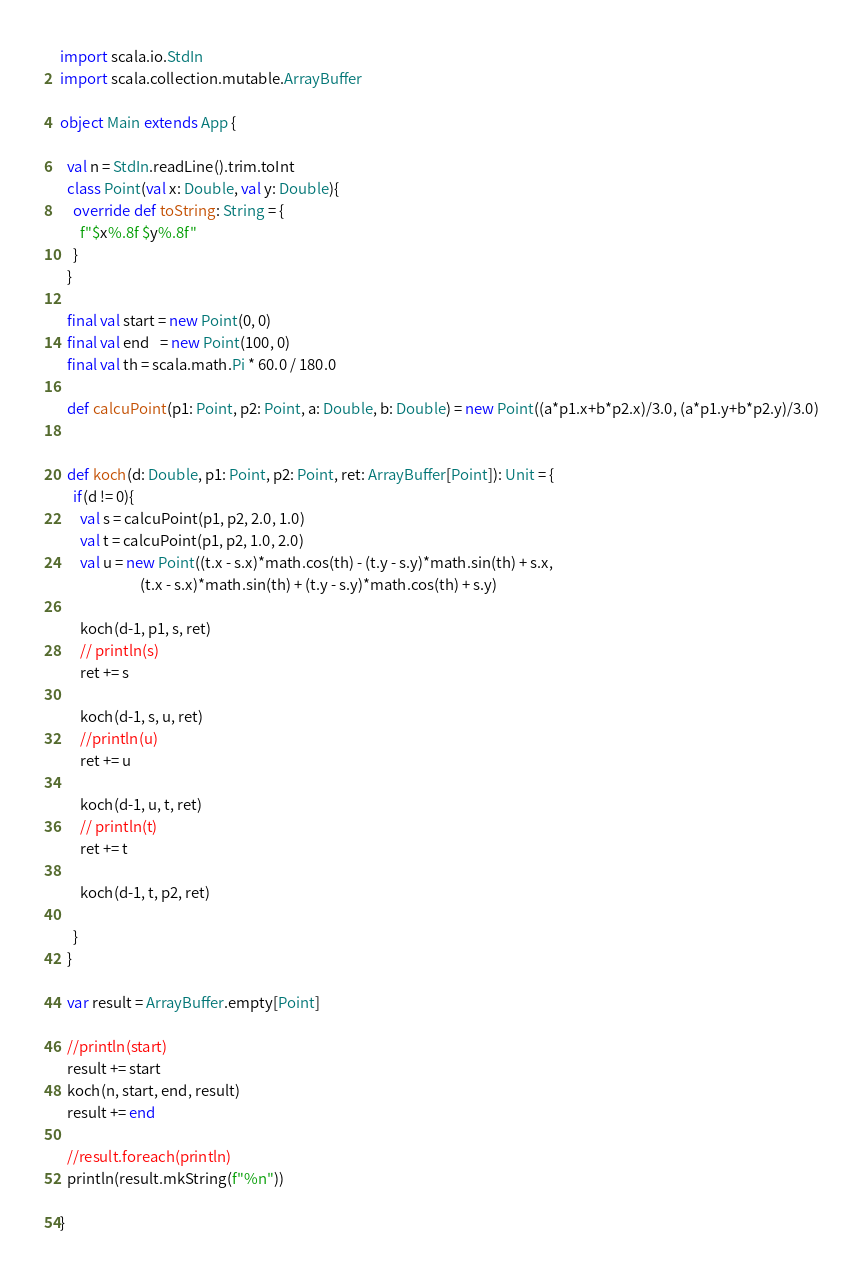<code> <loc_0><loc_0><loc_500><loc_500><_Scala_>import scala.io.StdIn
import scala.collection.mutable.ArrayBuffer

object Main extends App {

  val n = StdIn.readLine().trim.toInt
  class Point(val x: Double, val y: Double){
    override def toString: String = {
      f"$x%.8f $y%.8f"
    }
  }
  
  final val start = new Point(0, 0)
  final val end   = new Point(100, 0)
  final val th = scala.math.Pi * 60.0 / 180.0

  def calcuPoint(p1: Point, p2: Point, a: Double, b: Double) = new Point((a*p1.x+b*p2.x)/3.0, (a*p1.y+b*p2.y)/3.0)
  
  
  def koch(d: Double, p1: Point, p2: Point, ret: ArrayBuffer[Point]): Unit = {
    if(d != 0){
      val s = calcuPoint(p1, p2, 2.0, 1.0) 
      val t = calcuPoint(p1, p2, 1.0, 2.0)
      val u = new Point((t.x - s.x)*math.cos(th) - (t.y - s.y)*math.sin(th) + s.x,
                        (t.x - s.x)*math.sin(th) + (t.y - s.y)*math.cos(th) + s.y)
      
      koch(d-1, p1, s, ret)
      // println(s)
      ret += s
      
      koch(d-1, s, u, ret)
      //println(u)
      ret += u
      
      koch(d-1, u, t, ret)
      // println(t)
      ret += t

      koch(d-1, t, p2, ret)

    }
  }
  
  var result = ArrayBuffer.empty[Point]

  //println(start)
  result += start
  koch(n, start, end, result)
  result += end
  
  //result.foreach(println)
  println(result.mkString(f"%n"))
  
}
</code> 